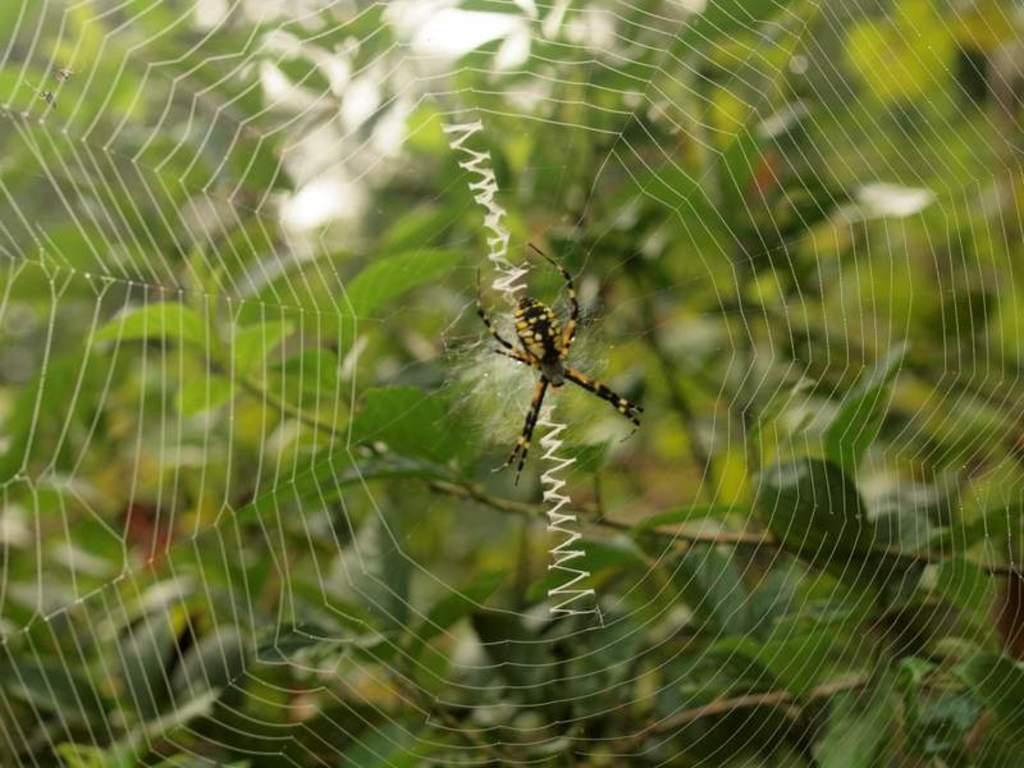What is the main subject of the picture? The main subject of the picture is a spider. Can you describe the appearance of the spider? The spider has black and yellow coloring. What is the spider doing in the picture? The spider is creating its web. What can be seen in the background of the image? There are trees in the background of the image. How is the background of the image depicted? The background of the image is blurred. What type of stocking is the spider using to create its web? There is no stocking present in the image; the spider is using its natural silk to create its web. What force is being applied by the spider to create its web? The question assumes that a force is being applied, but the image does not provide any information about the force involved in the spider's web creation. 